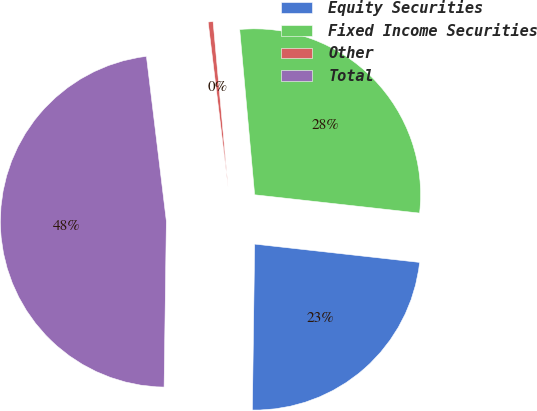Convert chart. <chart><loc_0><loc_0><loc_500><loc_500><pie_chart><fcel>Equity Securities<fcel>Fixed Income Securities<fcel>Other<fcel>Total<nl><fcel>23.46%<fcel>28.2%<fcel>0.48%<fcel>47.87%<nl></chart> 